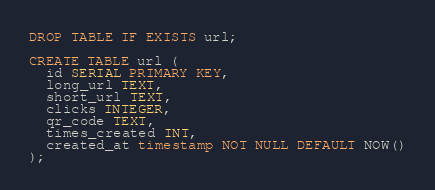Convert code to text. <code><loc_0><loc_0><loc_500><loc_500><_SQL_>DROP TABLE IF EXISTS url;

CREATE TABLE url (
  id SERIAL PRIMARY KEY,
  long_url TEXT,
  short_url TEXT,
  clicks INTEGER,
  qr_code TEXT,
  times_created INT,
  created_at timestamp NOT NULL DEFAULT NOW()
);</code> 